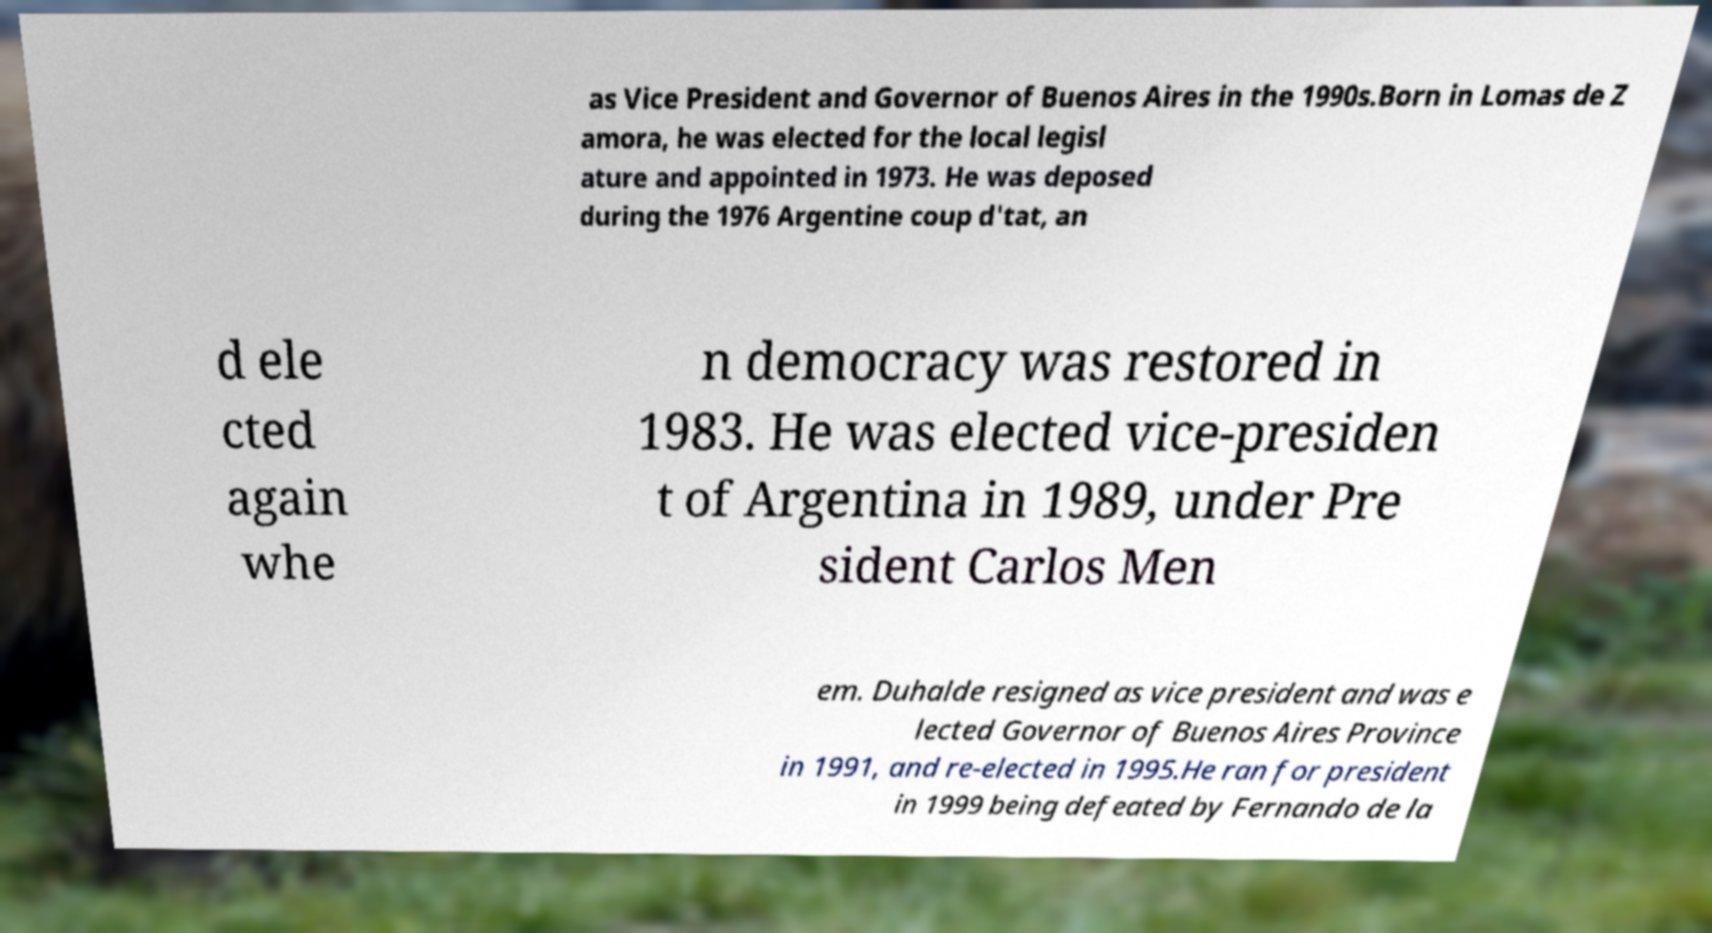I need the written content from this picture converted into text. Can you do that? as Vice President and Governor of Buenos Aires in the 1990s.Born in Lomas de Z amora, he was elected for the local legisl ature and appointed in 1973. He was deposed during the 1976 Argentine coup d'tat, an d ele cted again whe n democracy was restored in 1983. He was elected vice-presiden t of Argentina in 1989, under Pre sident Carlos Men em. Duhalde resigned as vice president and was e lected Governor of Buenos Aires Province in 1991, and re-elected in 1995.He ran for president in 1999 being defeated by Fernando de la 